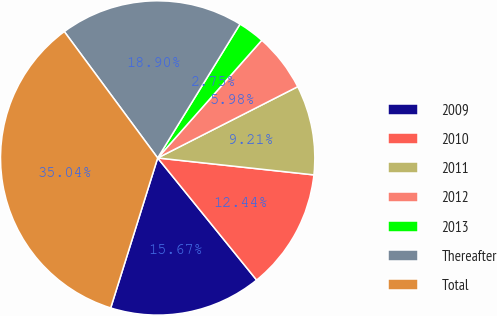<chart> <loc_0><loc_0><loc_500><loc_500><pie_chart><fcel>2009<fcel>2010<fcel>2011<fcel>2012<fcel>2013<fcel>Thereafter<fcel>Total<nl><fcel>15.67%<fcel>12.44%<fcel>9.21%<fcel>5.98%<fcel>2.75%<fcel>18.9%<fcel>35.04%<nl></chart> 